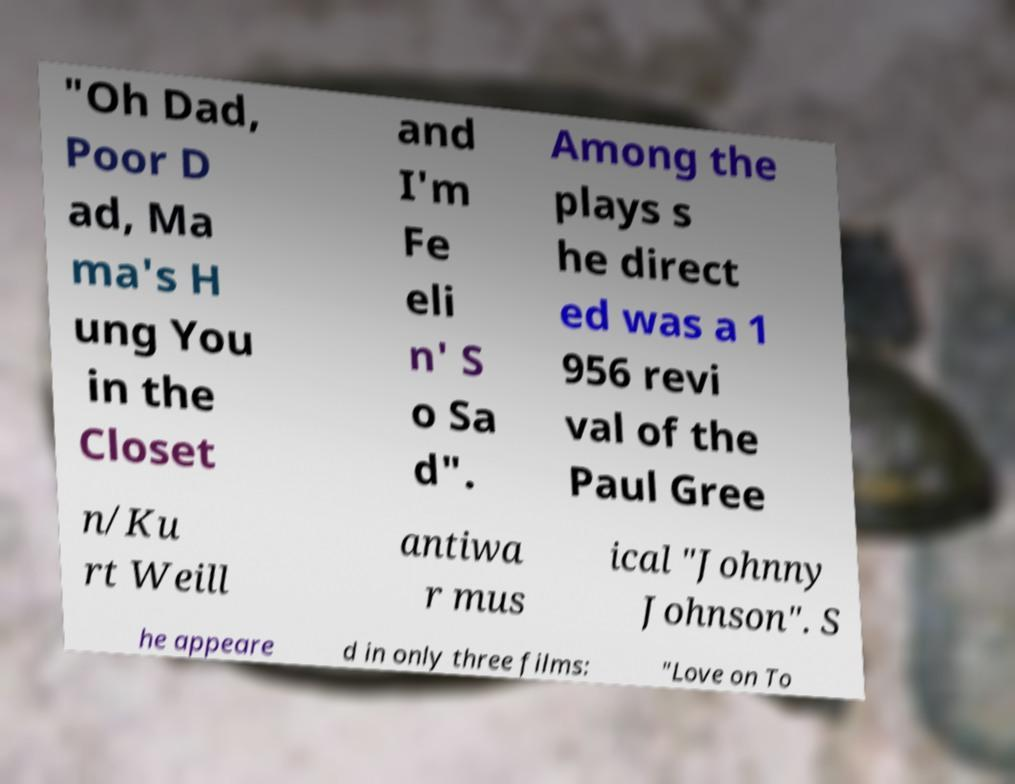Please read and relay the text visible in this image. What does it say? "Oh Dad, Poor D ad, Ma ma's H ung You in the Closet and I'm Fe eli n' S o Sa d". Among the plays s he direct ed was a 1 956 revi val of the Paul Gree n/Ku rt Weill antiwa r mus ical "Johnny Johnson". S he appeare d in only three films: "Love on To 